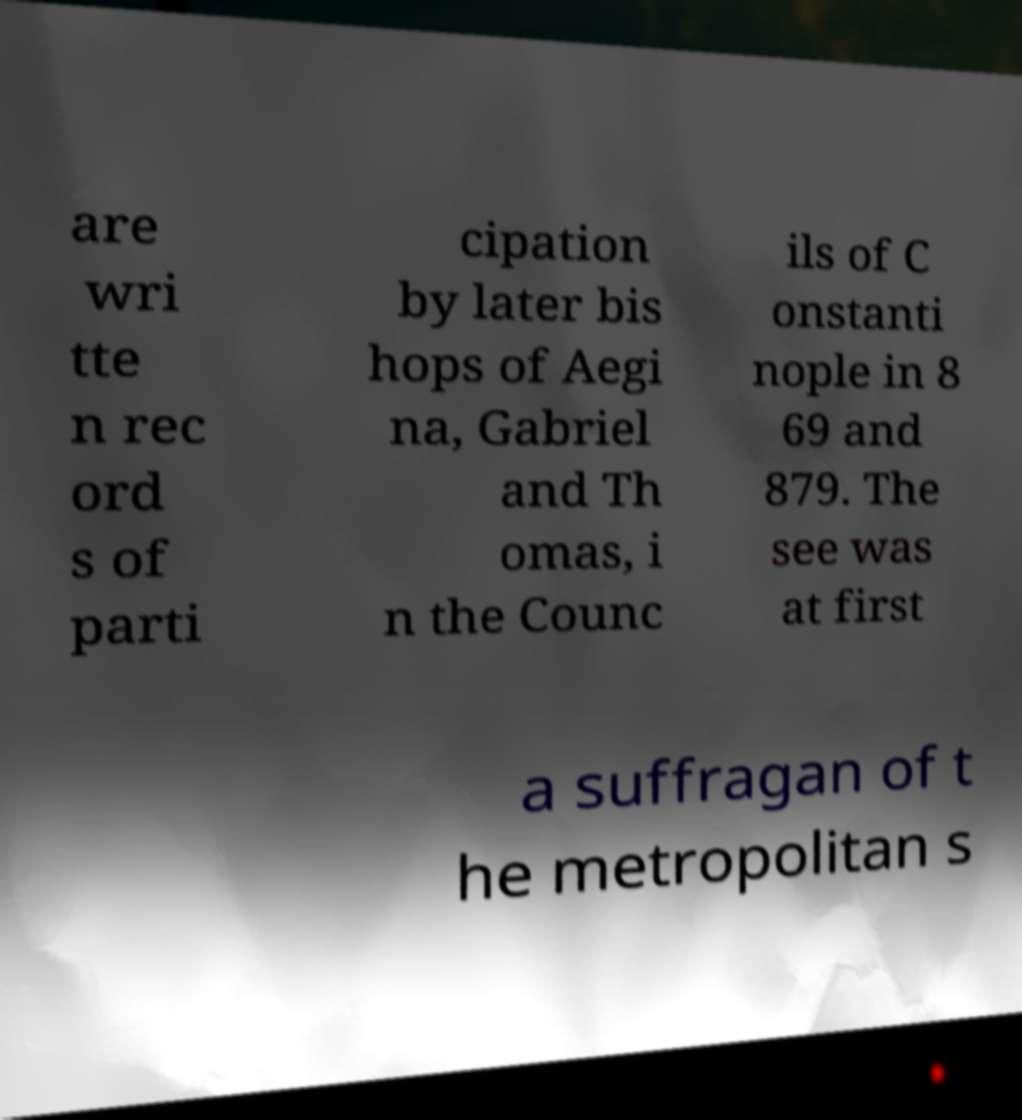Could you assist in decoding the text presented in this image and type it out clearly? are wri tte n rec ord s of parti cipation by later bis hops of Aegi na, Gabriel and Th omas, i n the Counc ils of C onstanti nople in 8 69 and 879. The see was at first a suffragan of t he metropolitan s 